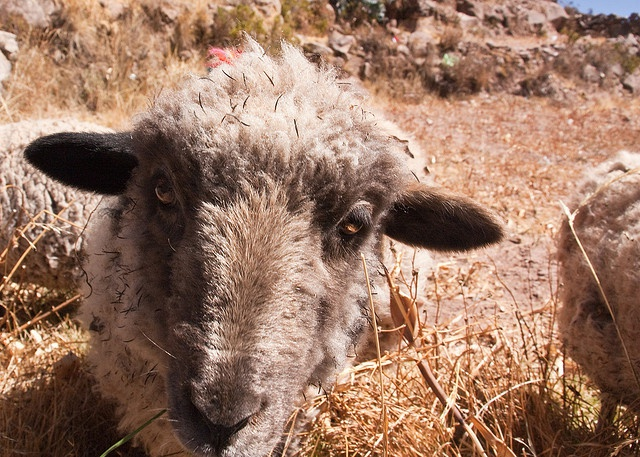Describe the objects in this image and their specific colors. I can see sheep in salmon, black, tan, lightgray, and maroon tones and sheep in salmon, maroon, brown, and black tones in this image. 